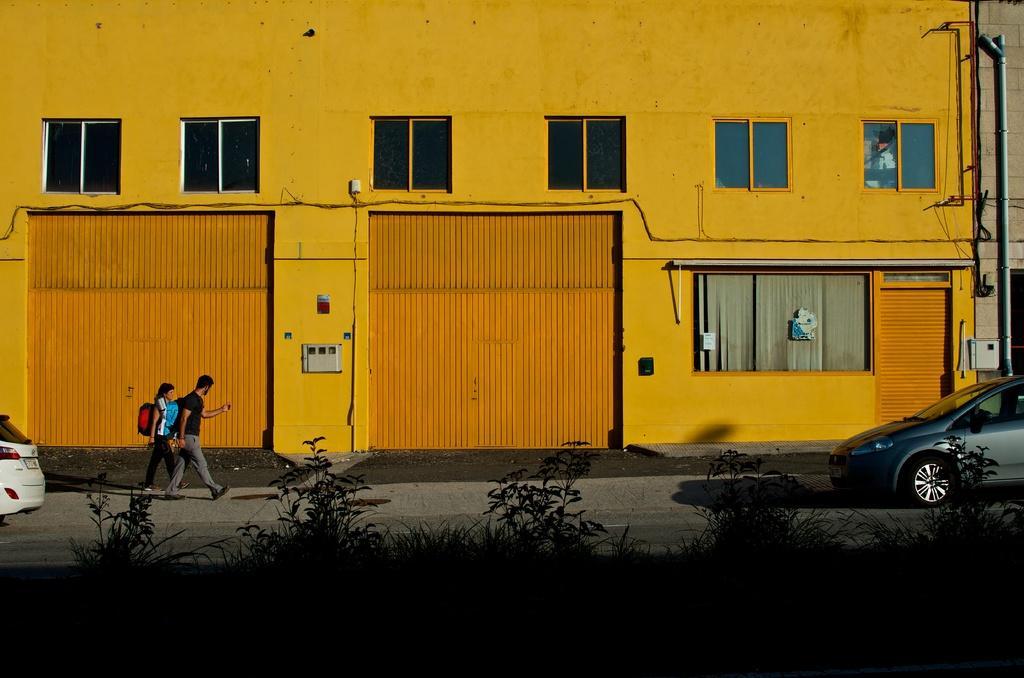How would you summarize this image in a sentence or two? In the foreground I can see grass, plants, two cars and two persons are walking on the road. In the background I can see buildings, windows, doors and a light pole. This image is taken may be on the road. 